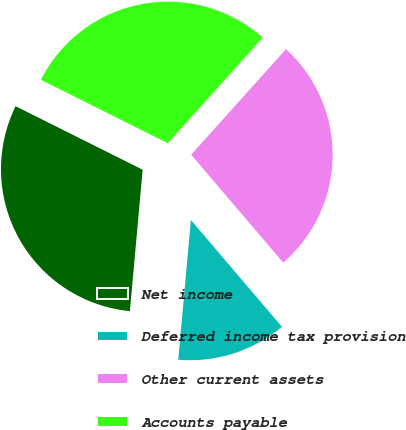Convert chart. <chart><loc_0><loc_0><loc_500><loc_500><pie_chart><fcel>Net income<fcel>Deferred income tax provision<fcel>Other current assets<fcel>Accounts payable<nl><fcel>30.94%<fcel>12.66%<fcel>27.12%<fcel>29.27%<nl></chart> 